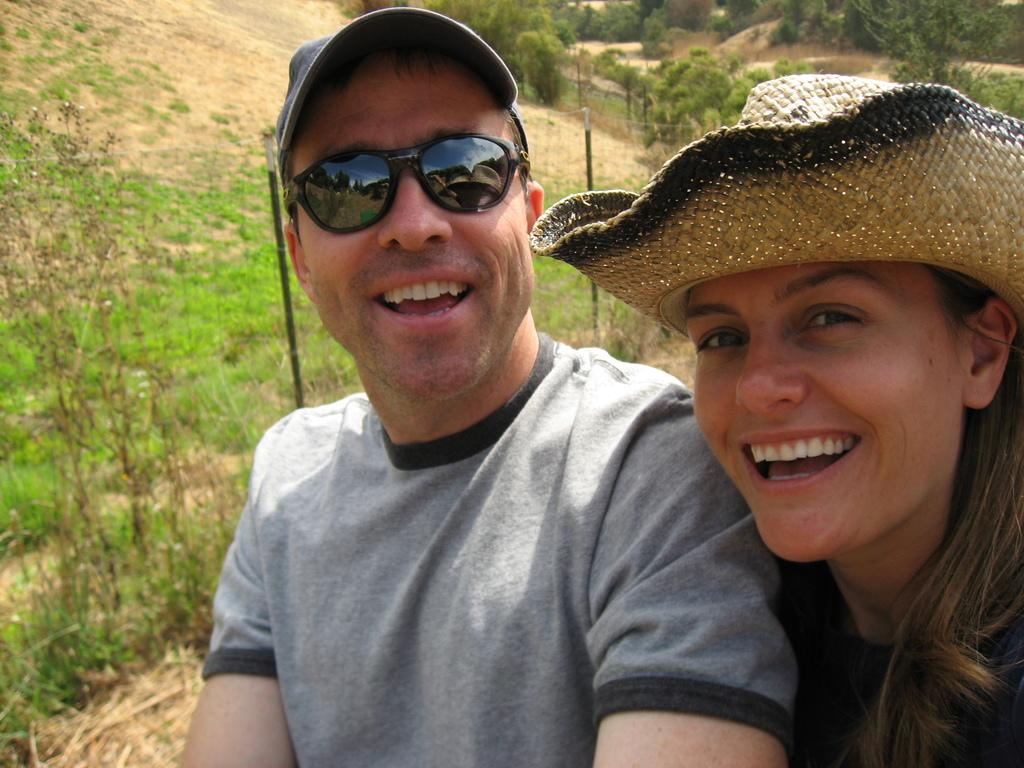Who are the people in the image? There is a lady and a man in the image. What are the lady and the man wearing on their heads? Both the lady and the man are wearing hats. Can you describe the man's appearance in the image? The man is wearing glasses. What can be seen in the background of the image? There are trees and grassland in the background of the image. How much money is the lady holding in the image? There is no indication of money in the image; the lady is not holding any. 